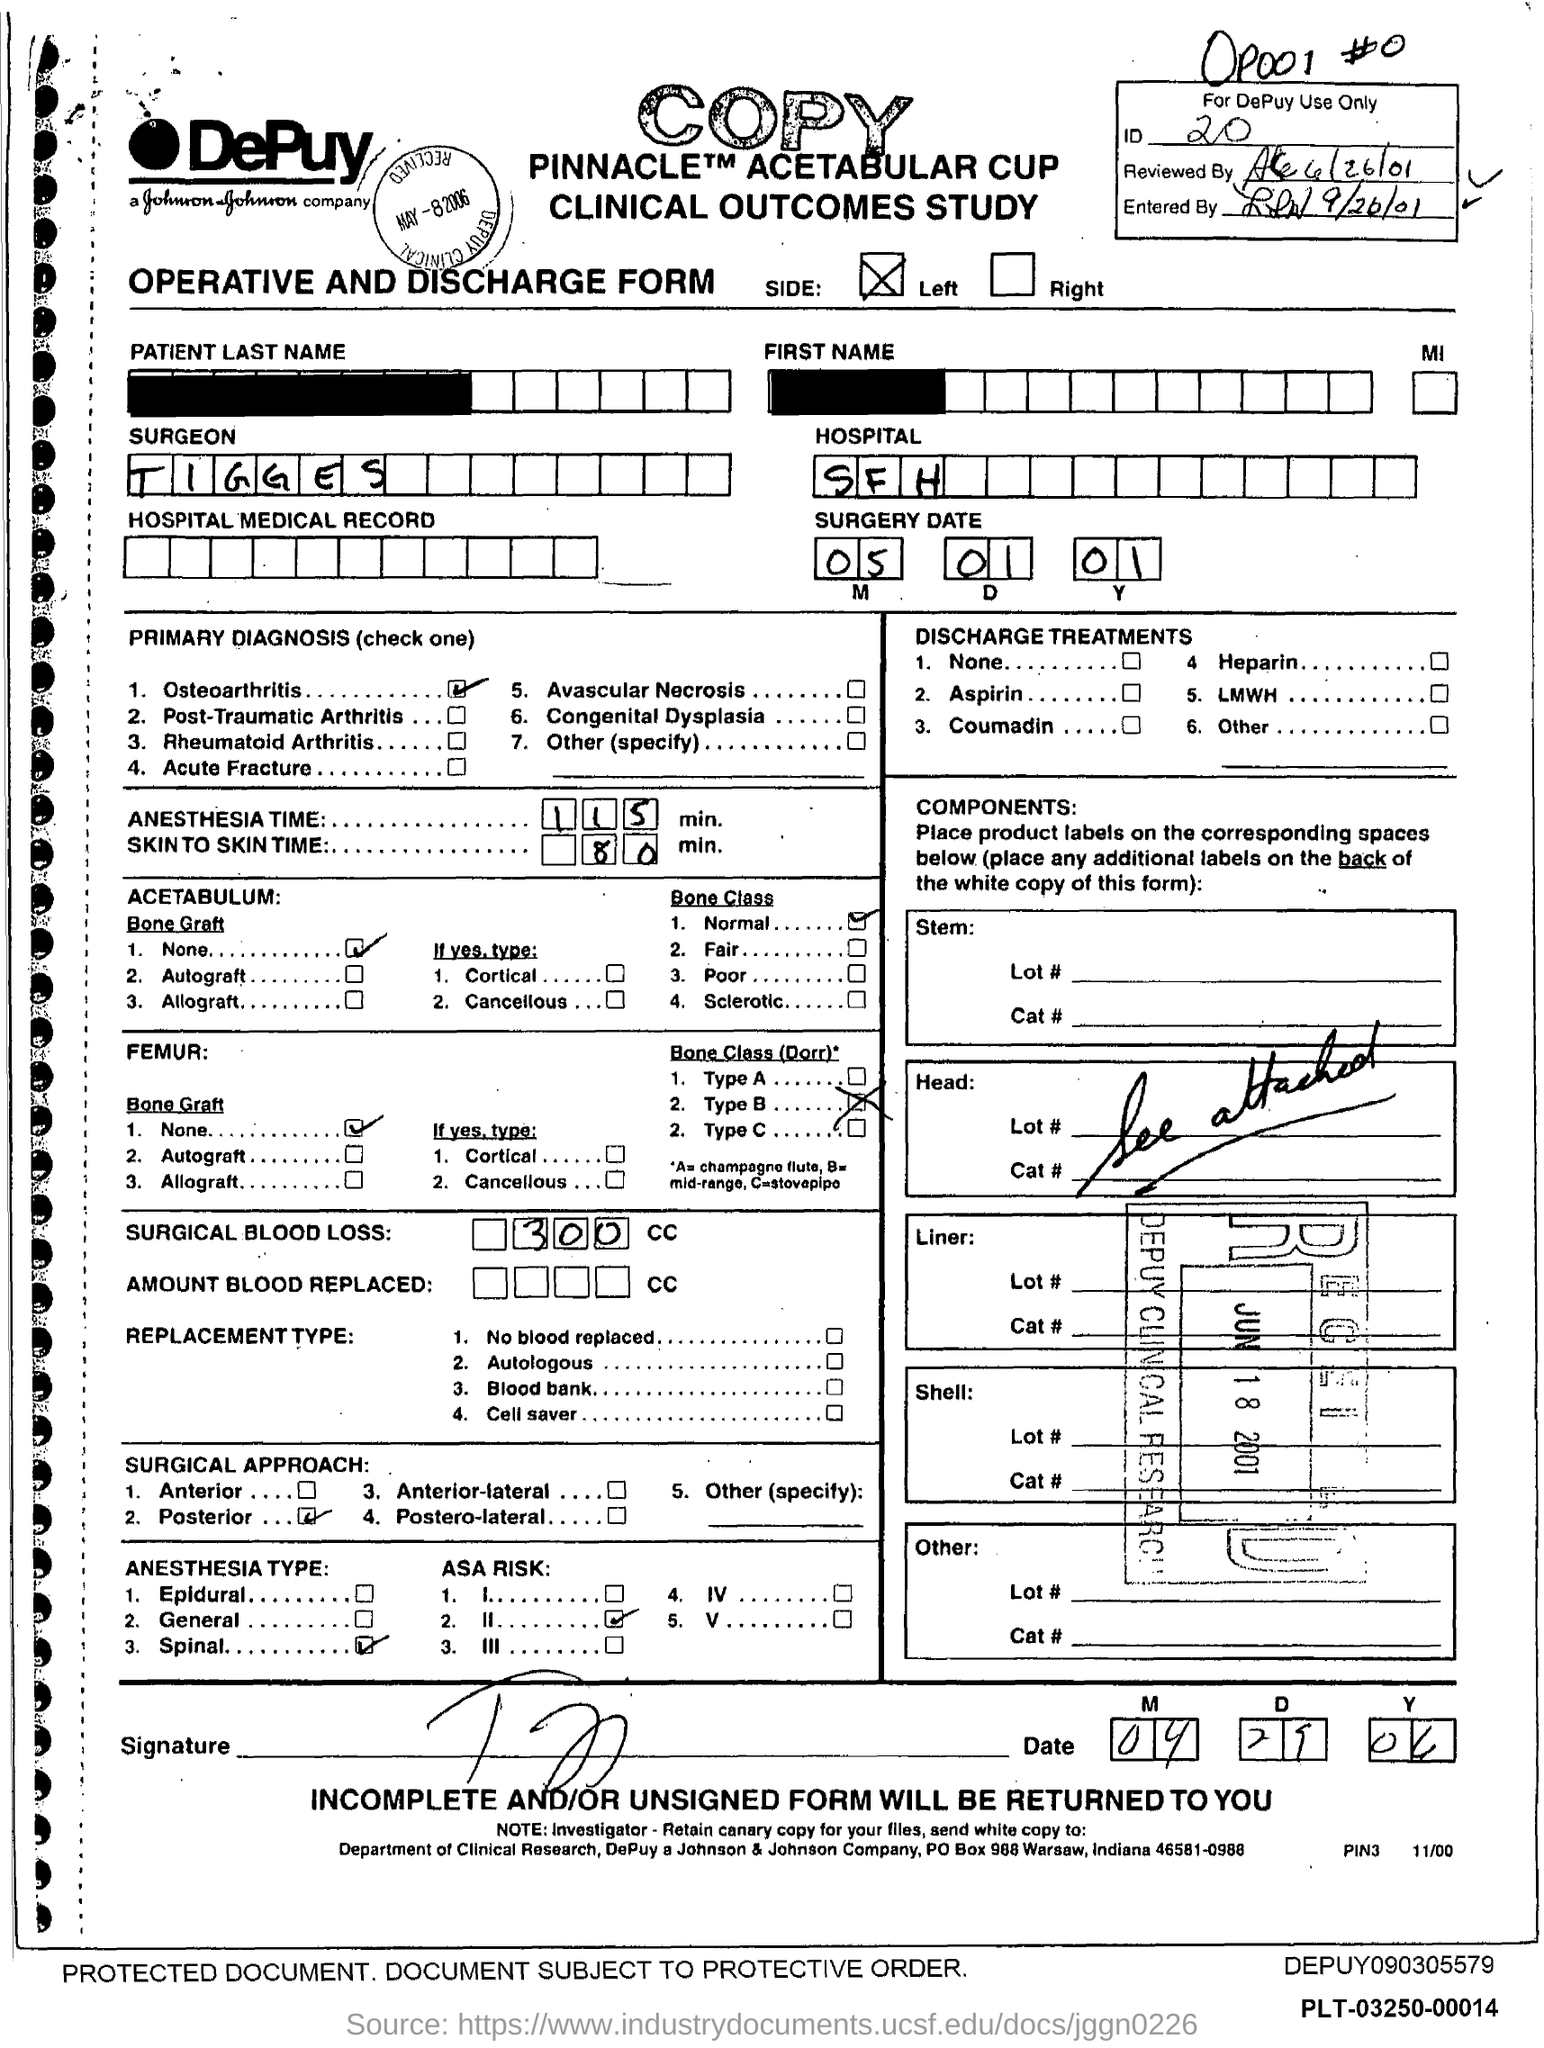Give some essential details in this illustration. The estimated anesthesia time for the surgery is 115 minutes. The ID mentioned in the form is 20... What type of form is given here? It is an operative and discharge form. The surgery date mentioned in the form is January 5, 2010. The surgery will take place at San Francisco Hospital. 